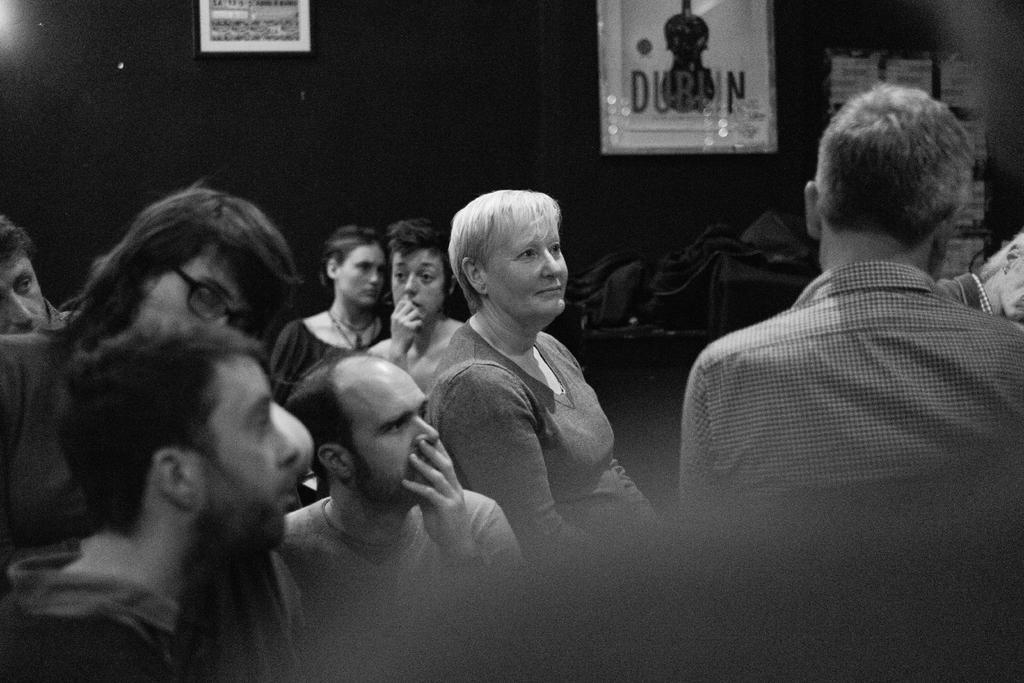How would you summarize this image in a sentence or two? In this picture there are some men and women sitting and watching to the right side. In the front there is a man sitting on the chair. Behind there is a black wall with two two photo frames. 